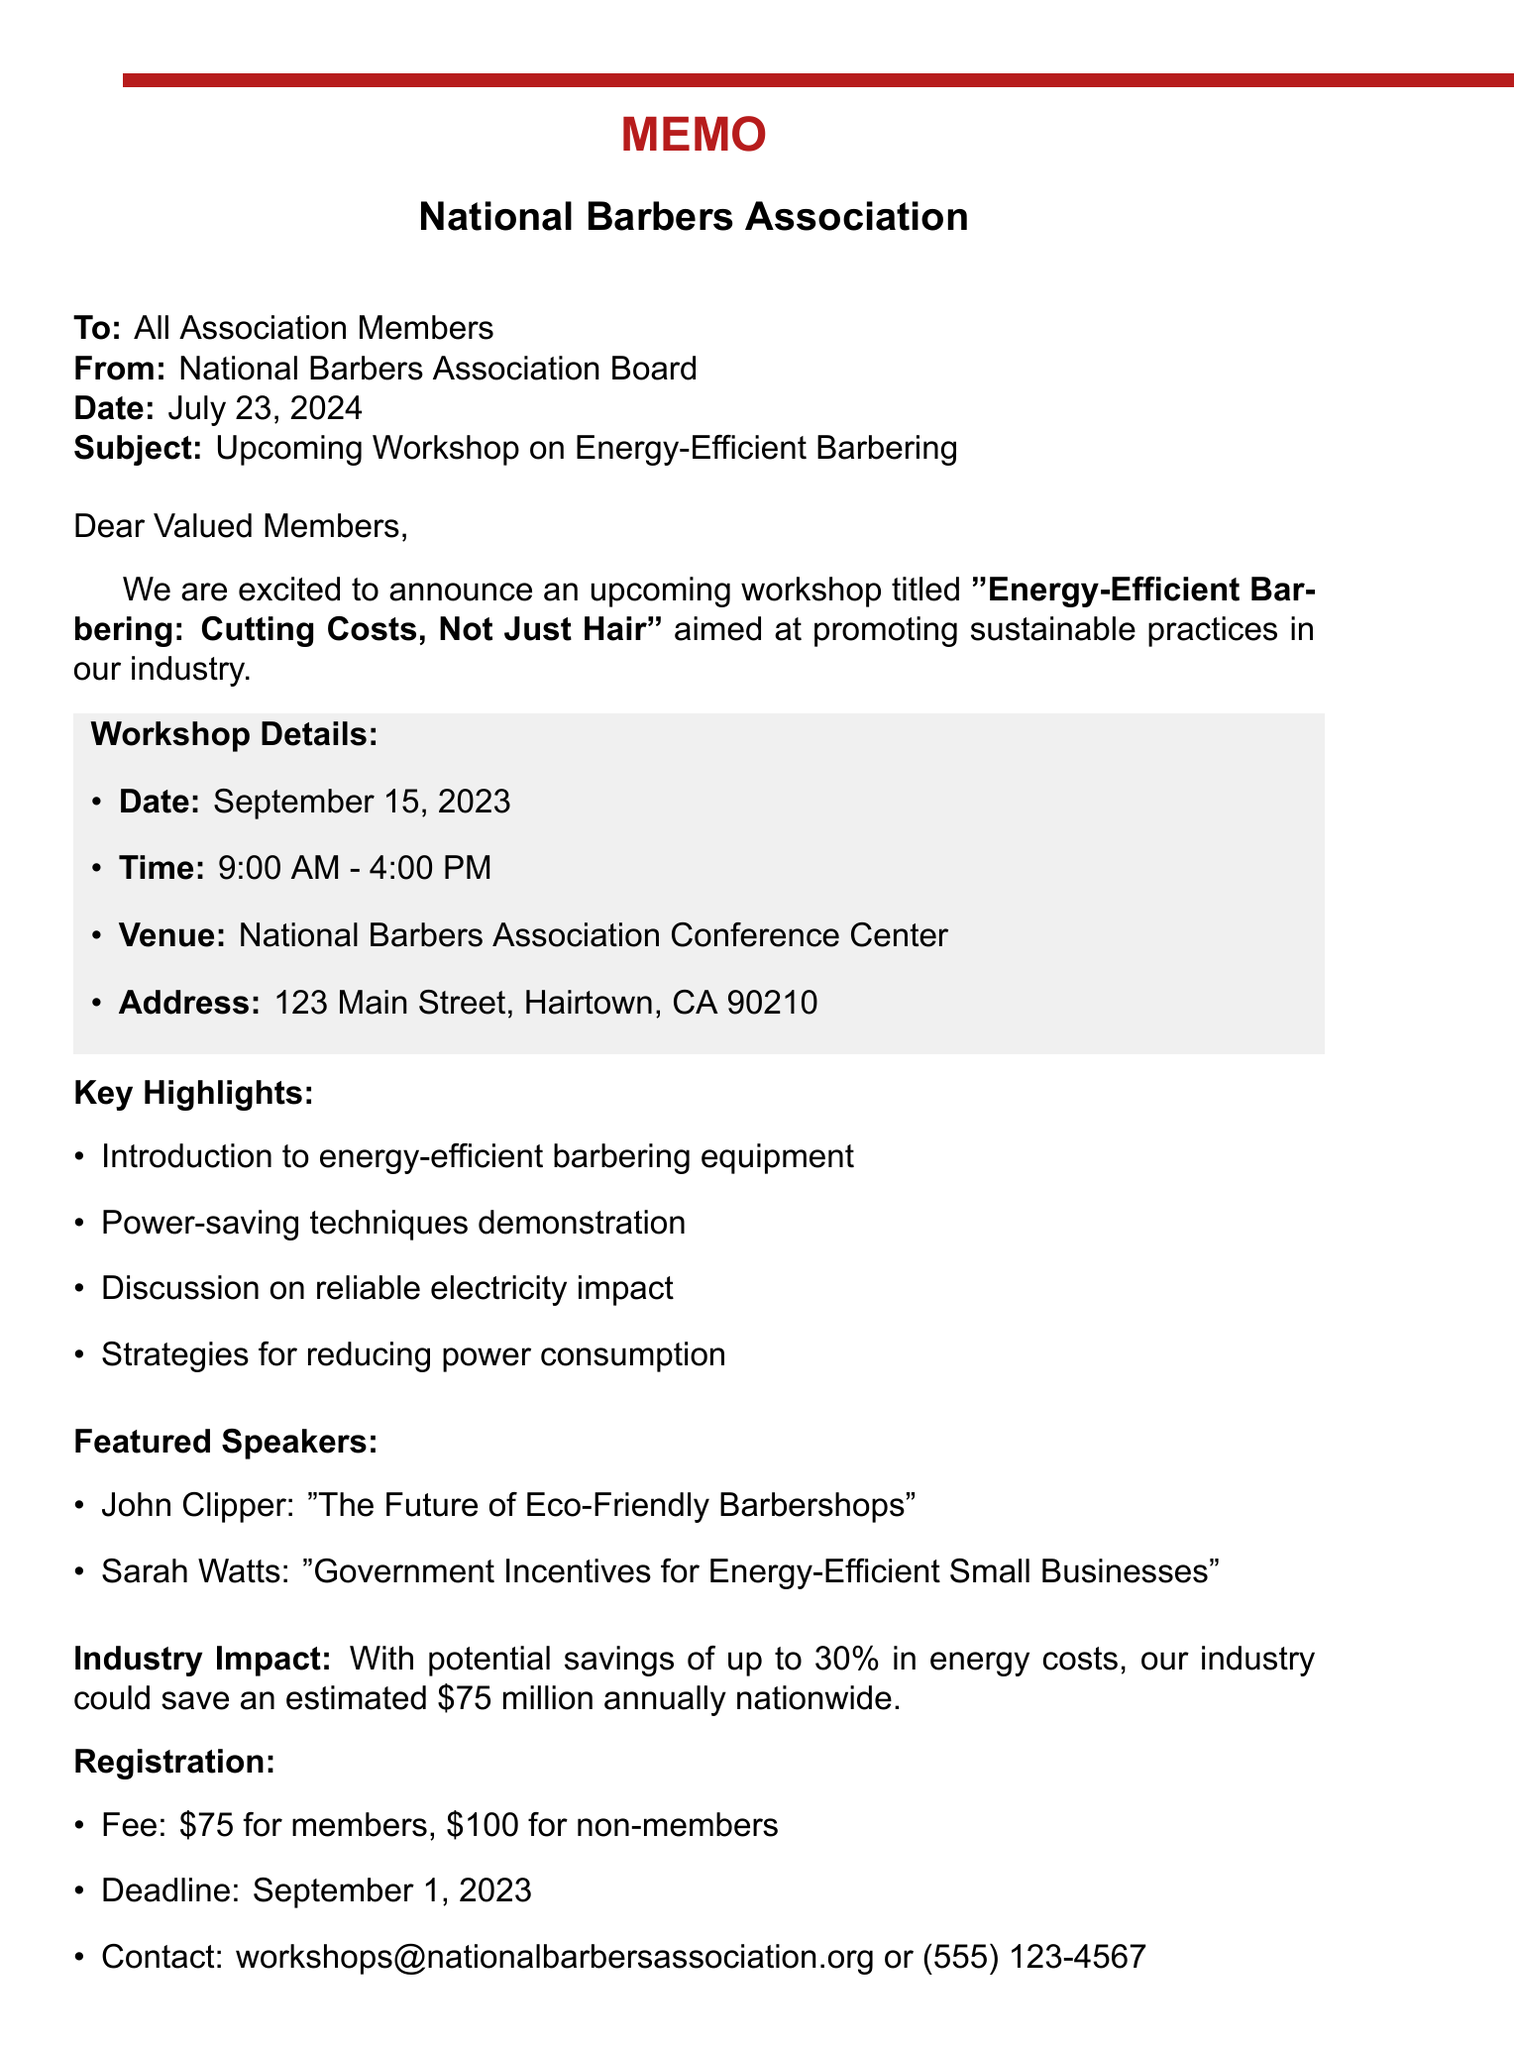What is the title of the workshop? The title of the workshop is stated in the document to be "Energy-Efficient Barbering: Cutting Costs, Not Just Hair."
Answer: Energy-Efficient Barbering: Cutting Costs, Not Just Hair What is the date of the workshop? The date of the workshop is explicitly mentioned in the document.
Answer: September 15, 2023 Who is one of the featured speakers? The document lists key speakers, one of whom is John Clipper.
Answer: John Clipper What is the cost for non-members to register? The registration fee for non-members is outlined in the document.
Answer: $100 What is the total potential savings for the industry annually? The document states that the estimated annual savings potential for the industry is $75 million.
Answer: $75 million How long is the workshop scheduled to last? The workshop runs from 9:00 AM to 4:00 PM, indicating its duration.
Answer: 7 hours What practices will the workshop discuss to reduce power consumption? The workshop objectives include discussing various strategies, such as implementing smart power strips.
Answer: Smart power strips When is the registration deadline? The document specifies a clear registration deadline for participants.
Answer: September 1, 2023 What is one of the equipment being showcased? The document provides details on energy-efficient equipment, one example being the EcoTrim 3000.
Answer: EcoTrim 3000 